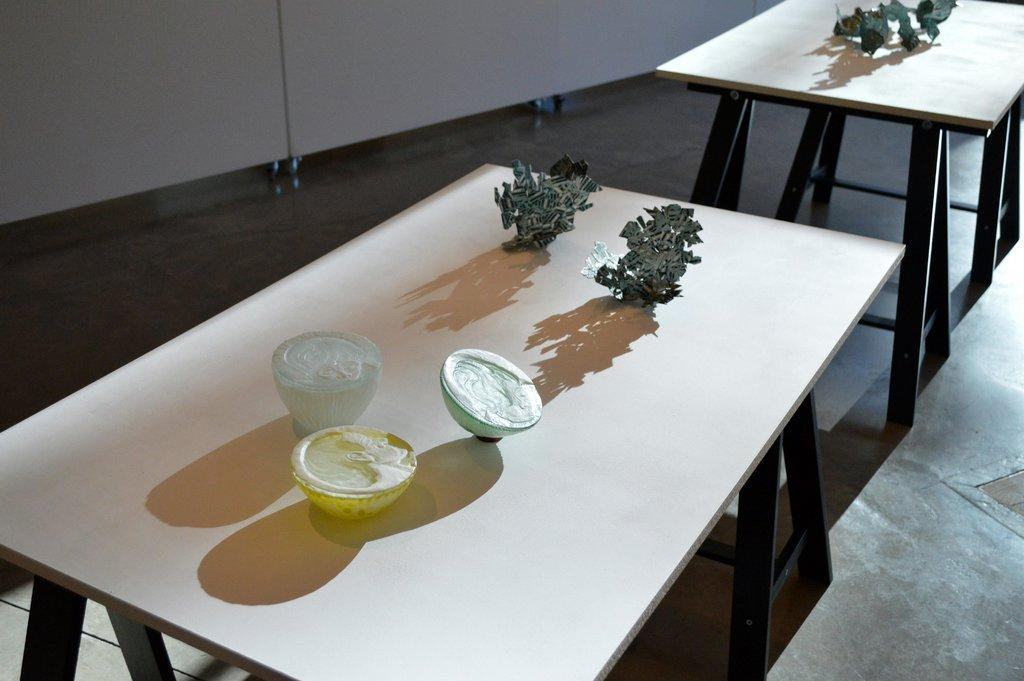How many tables are visible in the image? There is at least one table visible in the image. What can be found on the table(s) in the image? There are objects on the table(s) in the image. What type of birds are flying over the table in the image? There are no birds visible in the image; it only shows a table with objects on it. 